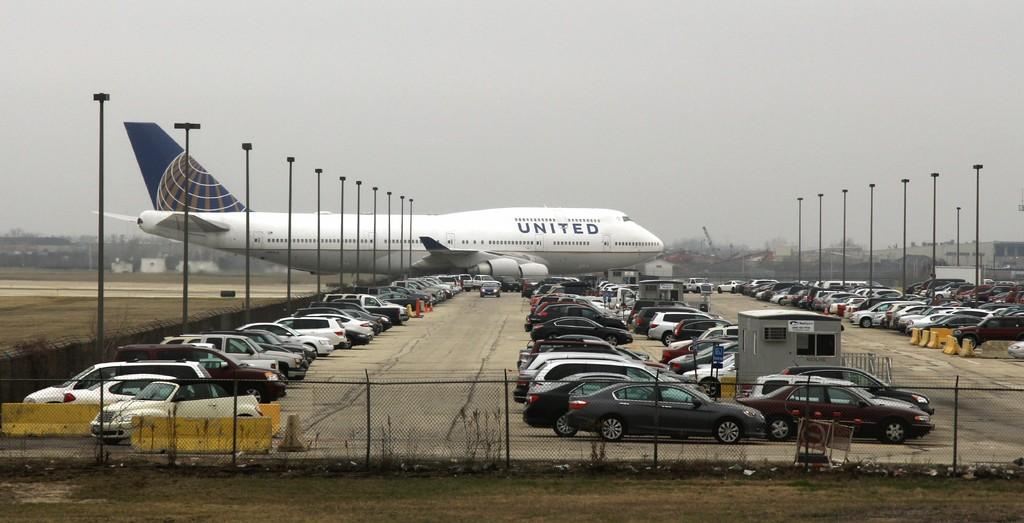<image>
Render a clear and concise summary of the photo. A large United Airlines passenger plane drives past a parking lot. 